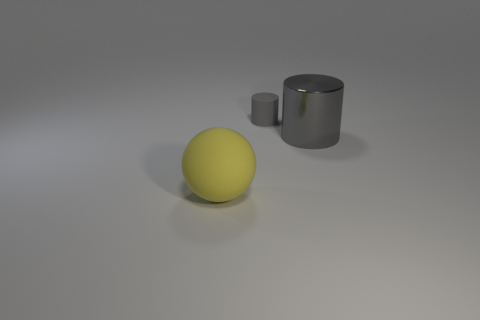Subtract all gray matte cylinders. Subtract all large yellow shiny cylinders. How many objects are left? 2 Add 1 big yellow spheres. How many big yellow spheres are left? 2 Add 3 gray cylinders. How many gray cylinders exist? 5 Add 2 big gray metal cylinders. How many objects exist? 5 Subtract 0 gray cubes. How many objects are left? 3 Subtract all spheres. How many objects are left? 2 Subtract 1 spheres. How many spheres are left? 0 Subtract all blue spheres. Subtract all blue cylinders. How many spheres are left? 1 Subtract all cyan blocks. How many green spheres are left? 0 